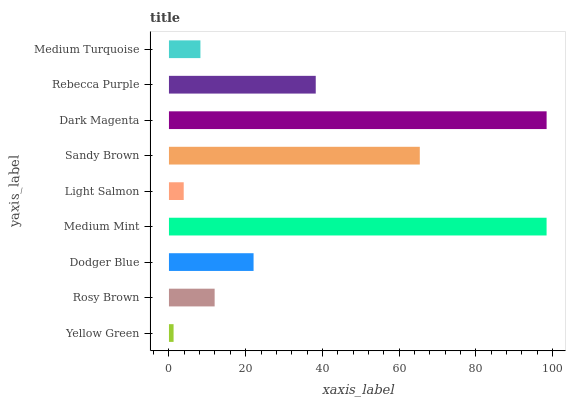Is Yellow Green the minimum?
Answer yes or no. Yes. Is Dark Magenta the maximum?
Answer yes or no. Yes. Is Rosy Brown the minimum?
Answer yes or no. No. Is Rosy Brown the maximum?
Answer yes or no. No. Is Rosy Brown greater than Yellow Green?
Answer yes or no. Yes. Is Yellow Green less than Rosy Brown?
Answer yes or no. Yes. Is Yellow Green greater than Rosy Brown?
Answer yes or no. No. Is Rosy Brown less than Yellow Green?
Answer yes or no. No. Is Dodger Blue the high median?
Answer yes or no. Yes. Is Dodger Blue the low median?
Answer yes or no. Yes. Is Sandy Brown the high median?
Answer yes or no. No. Is Rosy Brown the low median?
Answer yes or no. No. 